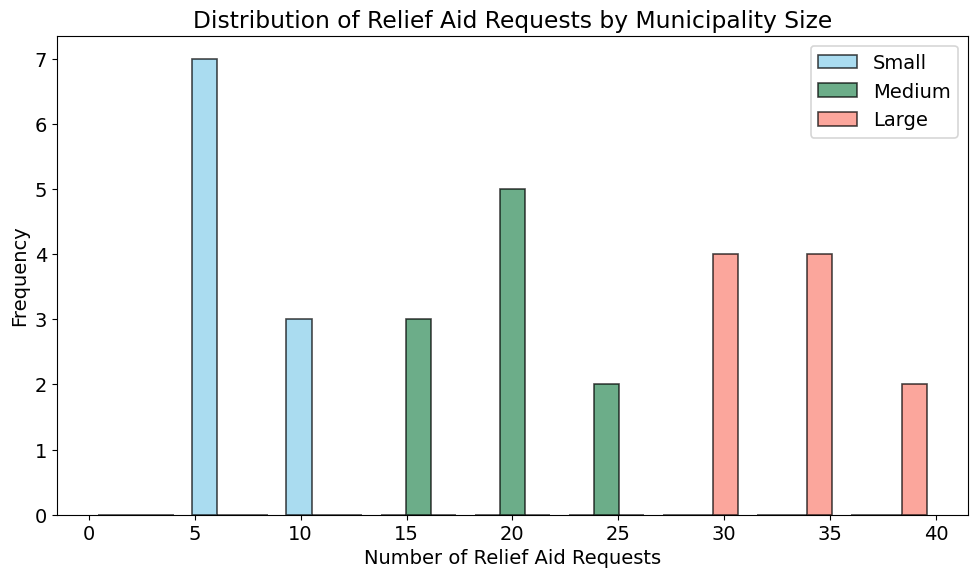What does the histogram represent? The histogram shows the distribution of relief aid requests categorized by municipality size (Small, Medium, Large). It represents how frequently different numbers of requests appear for each municipality size using bars.
Answer: Distribution of relief aid requests by municipality size Which municipality size has the highest frequency for the range 15 to 25 relief aid requests? In the histogram, the Medium municipality size has the highest frequency for the range of 15 to 25 relief aid requests. This is evident from the tallest bars in that range being green, which corresponds to the Medium category.
Answer: Medium How do the frequencies of Small and Large municipalities compare for the range 5 to 15 relief aid requests? For the range of 5 to 15 relief aid requests, the Small municipality has higher frequencies compared to the Large municipality. There are more blue bars (representing Small municipalities) within this range and fewer or no red bars (representing Large municipalities).
Answer: Small has higher frequencies What is the most common range of relief aid requests for Medium municipalities? The most common range for Medium municipalities appears to be between 15 to 25 based on the highest frequency observed for the green bars within this range.
Answer: 15 to 25 Which municipality size has the smallest spread in the number of relief aid requests? The Small municipality size has the smallest range of relief aid requests, observable from the narrower span of blue bars compared to the Medium and Large groups.
Answer: Small Is there a range where all three municipality sizes overlap in terms of relief aid requests? Yes, the range of 10 to 15 relief aid requests has overlapping frequencies for all three municipality sizes, indicated by the presence of blue, green, and red bars in that section.
Answer: 10 to 15 What is the difference in the maximum number of relief aid requests between Small and Large municipalities? The maximum number of relief aid requests for Small municipalities is 12, and for Large municipalities, it's 37. The difference is calculated as 37 - 12.
Answer: 25 What range of relief aid requests is least common among Large municipalities? The least common range for Large municipalities is from 0 to 10, indicated by the absence or very low height of red bars in this range.
Answer: 0 to 10 What visual characteristic helps to distinguish between the three municipality sizes in the histogram? The different municipality sizes are distinguished by color: blue for Small, green for Medium, and red for Large, combined with varying bar heights.
Answer: Color and height of bars What can you infer about the average relief aid requests for Large municipalities based on the histogram's shape? The bars representing Large municipalities (red) are generally concentrated around higher ranges like 25 to 40, indicating that the average relief aid requests for Large municipalities are relatively high compared to Small and Medium municipalities.
Answer: Relatively high 